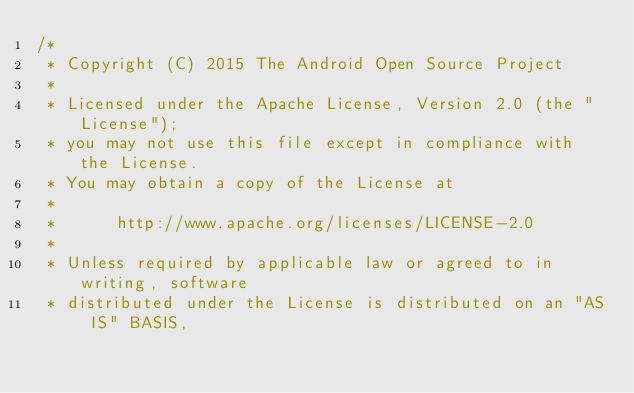<code> <loc_0><loc_0><loc_500><loc_500><_C_>/*
 * Copyright (C) 2015 The Android Open Source Project
 *
 * Licensed under the Apache License, Version 2.0 (the "License");
 * you may not use this file except in compliance with the License.
 * You may obtain a copy of the License at
 *
 *      http://www.apache.org/licenses/LICENSE-2.0
 *
 * Unless required by applicable law or agreed to in writing, software
 * distributed under the License is distributed on an "AS IS" BASIS,</code> 